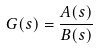Convert formula to latex. <formula><loc_0><loc_0><loc_500><loc_500>G ( s ) = \frac { A ( s ) } { B ( s ) }</formula> 